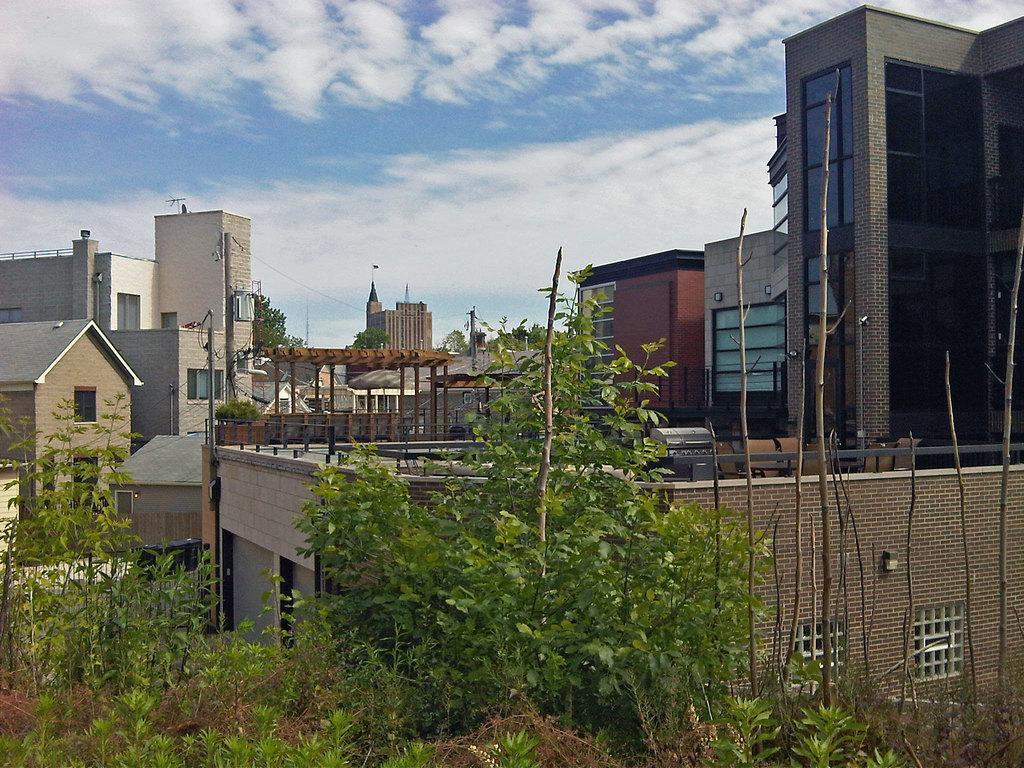Describe this image in one or two sentences. In this image there is the sky, there are clouds in the sky, there are buildings, there are building truncated towards the right of the image, there are building truncated towards the left of the image, there are trees truncated towards the bottom of the image, there are poles. 